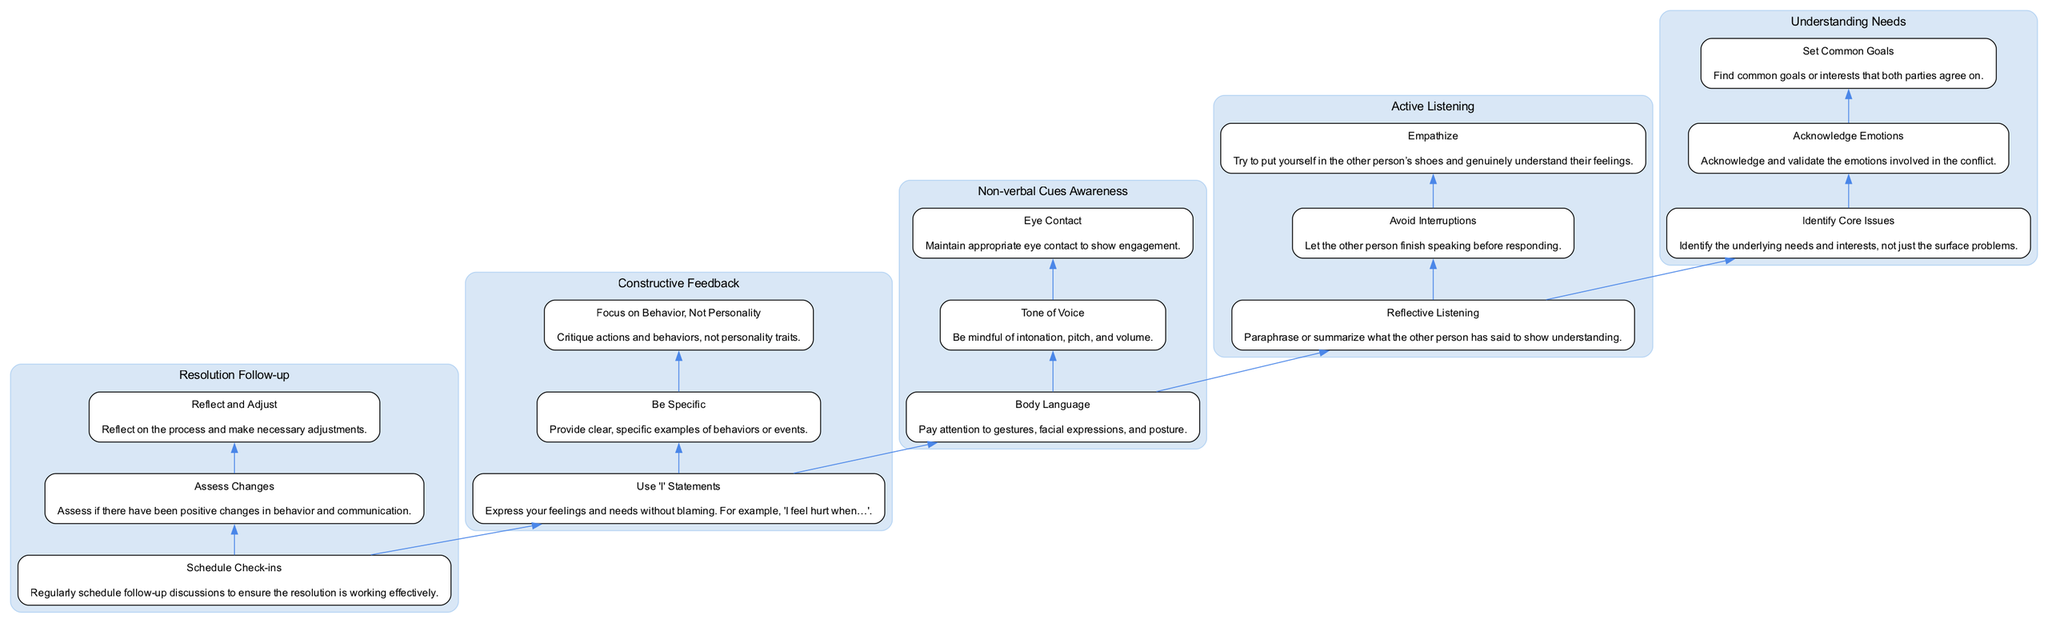What is the topmost component of the diagram? The diagram is structured in a bottom-to-up flow where components build upon each other, and the topmost component is "Resolution Follow-up."
Answer: Resolution Follow-up How many sub-steps are under "Constructive Feedback"? By examining the "Constructive Feedback" main step, there are three distinct sub-steps listed within it: "Use 'I' Statements," "Be Specific," and "Focus on Behavior, Not Personality."
Answer: 3 Which main step directly precedes "Active Listening"? In the flow diagram, "Understanding Needs" is the main step that directly flows into "Active Listening," indicating it is the previous step.
Answer: Understanding Needs What type of statements should be used according to "Constructive Feedback"? The "Constructive Feedback" sub-step specifies using "'I' Statements" to express feelings and needs without blaming the other person.
Answer: 'I' Statements What is the first sub-step in "Non-verbal Cues Awareness"? When looking at the listed sub-steps for "Non-verbal Cues Awareness," the first sub-step mentioned is "Body Language."
Answer: Body Language What are the components leading to "Resolution Follow-up"? The flow leading to "Resolution Follow-up" includes all prior steps: "Constructive Feedback," "Non-verbal Cues Awareness," "Active Listening," and "Understanding Needs," indicating the sequence that must be followed to reach this point.
Answer: Constructive Feedback, Non-verbal Cues Awareness, Active Listening, Understanding Needs How does "Active Listening" influence "Constructive Feedback"? "Active Listening" is positioned before "Constructive Feedback" in the flow, suggesting that effective listening is essential for providing meaningful feedback, thereby indicating an influence where understanding precedes critique.
Answer: Active Listening influences Constructive Feedback What needs to happen after resolution is reached? According to the "Resolution Follow-up" step, it specifies several actions that should occur post-resolution, with "Schedule Check-ins" being one of the key actions to ensure ongoing effectiveness.
Answer: Schedule Check-ins 